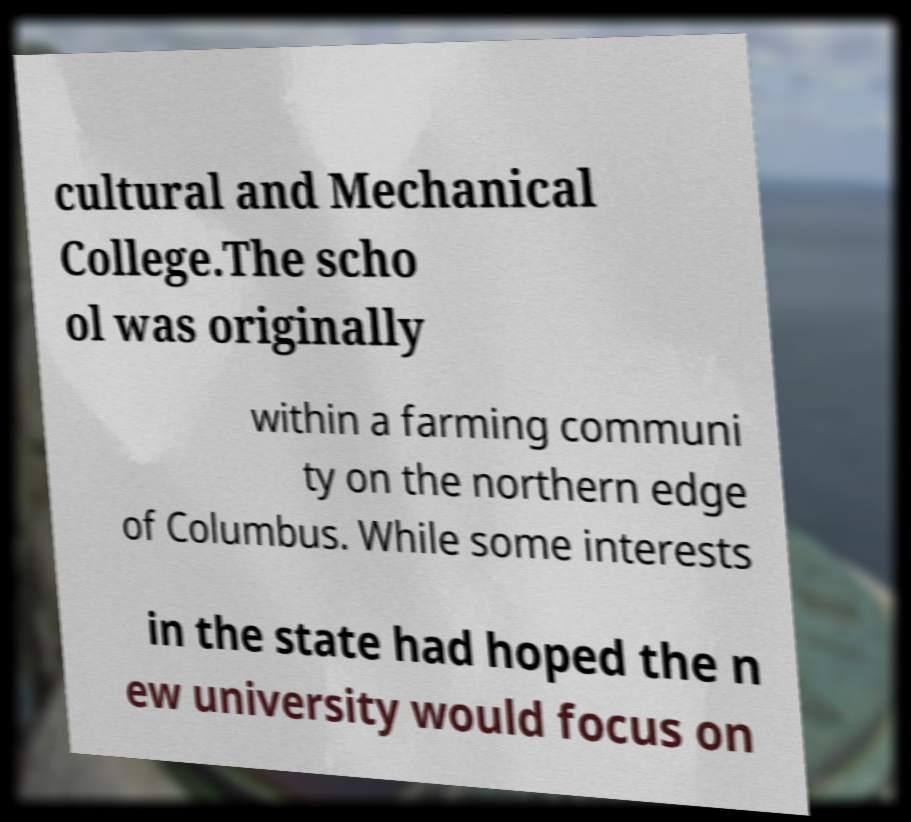Could you extract and type out the text from this image? cultural and Mechanical College.The scho ol was originally within a farming communi ty on the northern edge of Columbus. While some interests in the state had hoped the n ew university would focus on 